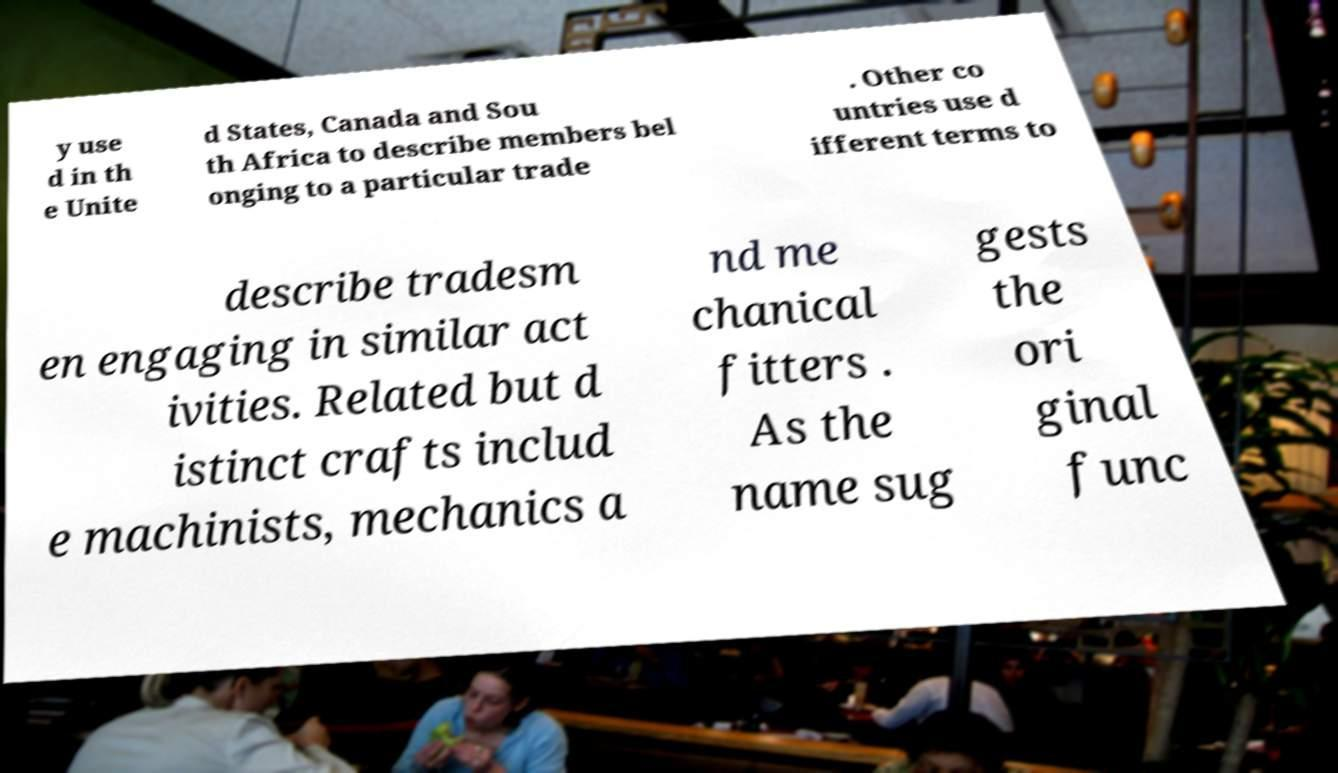There's text embedded in this image that I need extracted. Can you transcribe it verbatim? y use d in th e Unite d States, Canada and Sou th Africa to describe members bel onging to a particular trade . Other co untries use d ifferent terms to describe tradesm en engaging in similar act ivities. Related but d istinct crafts includ e machinists, mechanics a nd me chanical fitters . As the name sug gests the ori ginal func 